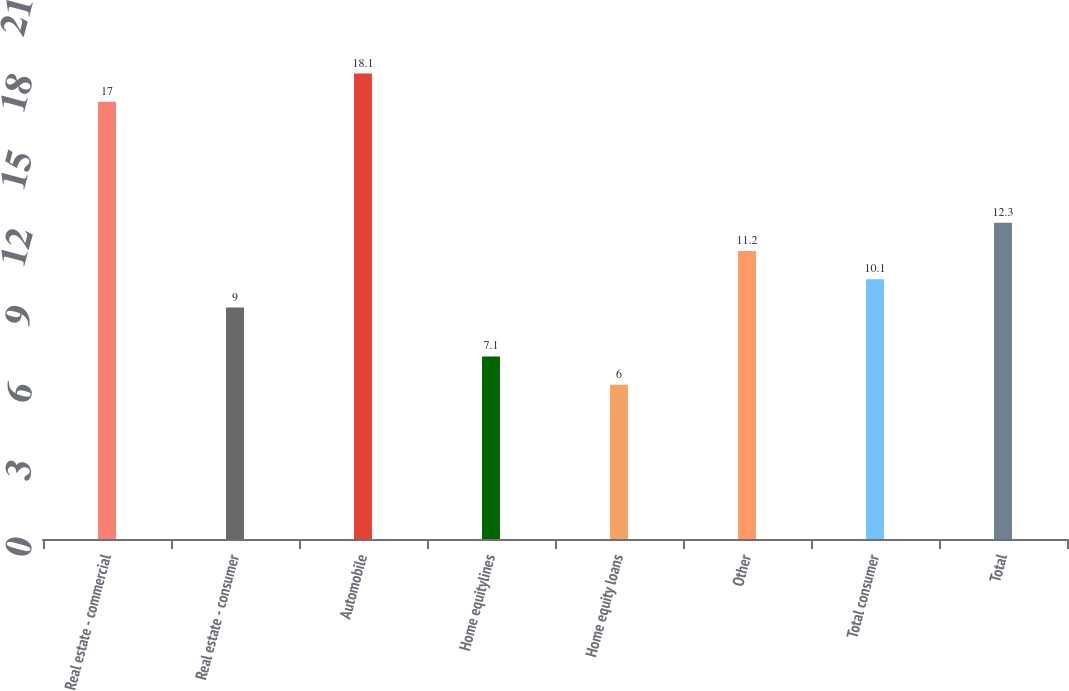Convert chart to OTSL. <chart><loc_0><loc_0><loc_500><loc_500><bar_chart><fcel>Real estate - commercial<fcel>Real estate - consumer<fcel>Automobile<fcel>Home equitylines<fcel>Home equity loans<fcel>Other<fcel>Total consumer<fcel>Total<nl><fcel>17<fcel>9<fcel>18.1<fcel>7.1<fcel>6<fcel>11.2<fcel>10.1<fcel>12.3<nl></chart> 